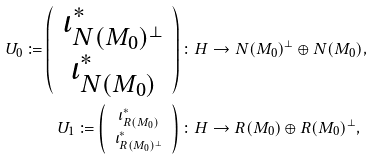Convert formula to latex. <formula><loc_0><loc_0><loc_500><loc_500>U _ { 0 } \coloneqq \left ( \begin{array} { c } \iota _ { N ( M _ { 0 } ) ^ { \bot } } ^ { \ast } \\ \iota _ { N ( M _ { 0 } ) } ^ { \ast } \end{array} \right ) \colon H & \to N ( M _ { 0 } ) ^ { \bot } \oplus N ( M _ { 0 } ) , \\ U _ { 1 } \coloneqq \left ( \begin{array} { c } \iota _ { R ( M _ { 0 } ) } ^ { \ast } \\ \iota _ { R ( M _ { 0 } ) ^ { \bot } } ^ { \ast } \end{array} \right ) \colon H & \to R ( M _ { 0 } ) \oplus R ( M _ { 0 } ) ^ { \bot } ,</formula> 